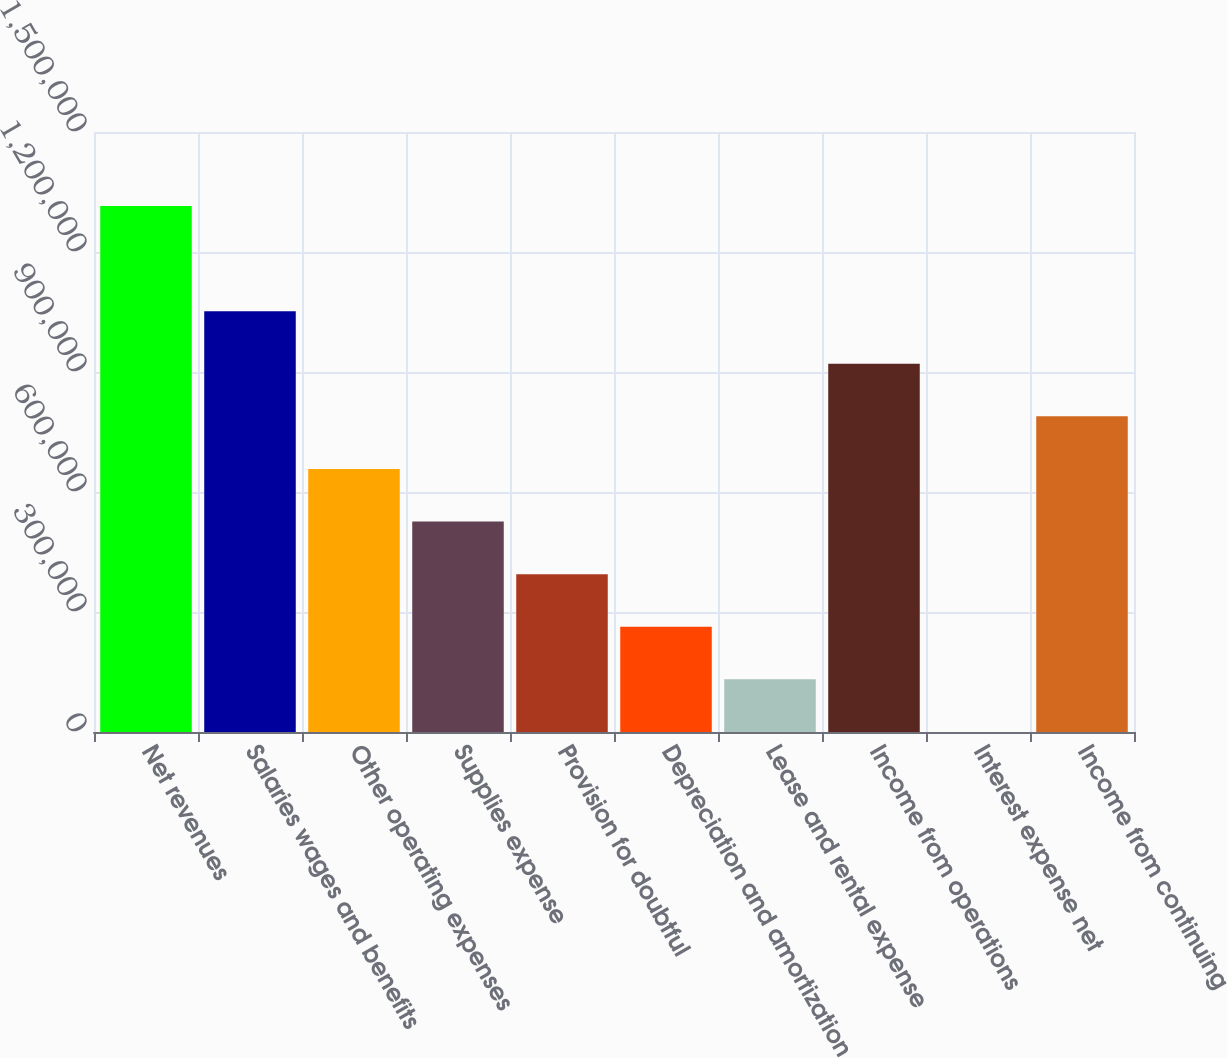<chart> <loc_0><loc_0><loc_500><loc_500><bar_chart><fcel>Net revenues<fcel>Salaries wages and benefits<fcel>Other operating expenses<fcel>Supplies expense<fcel>Provision for doubtful<fcel>Depreciation and amortization<fcel>Lease and rental expense<fcel>Income from operations<fcel>Interest expense net<fcel>Income from continuing<nl><fcel>1.31503e+06<fcel>1.05206e+06<fcel>657619<fcel>526137<fcel>394655<fcel>263173<fcel>131691<fcel>920583<fcel>209<fcel>789101<nl></chart> 